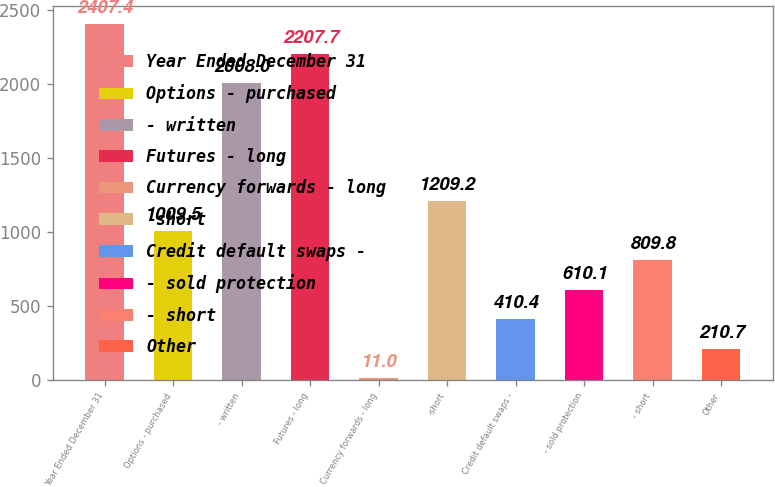Convert chart to OTSL. <chart><loc_0><loc_0><loc_500><loc_500><bar_chart><fcel>Year Ended December 31<fcel>Options - purchased<fcel>- written<fcel>Futures - long<fcel>Currency forwards - long<fcel>-short<fcel>Credit default swaps -<fcel>- sold protection<fcel>- short<fcel>Other<nl><fcel>2407.4<fcel>1009.5<fcel>2008<fcel>2207.7<fcel>11<fcel>1209.2<fcel>410.4<fcel>610.1<fcel>809.8<fcel>210.7<nl></chart> 